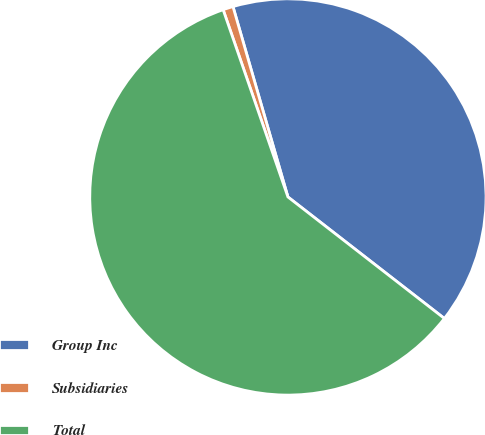<chart> <loc_0><loc_0><loc_500><loc_500><pie_chart><fcel>Group Inc<fcel>Subsidiaries<fcel>Total<nl><fcel>39.98%<fcel>0.83%<fcel>59.19%<nl></chart> 